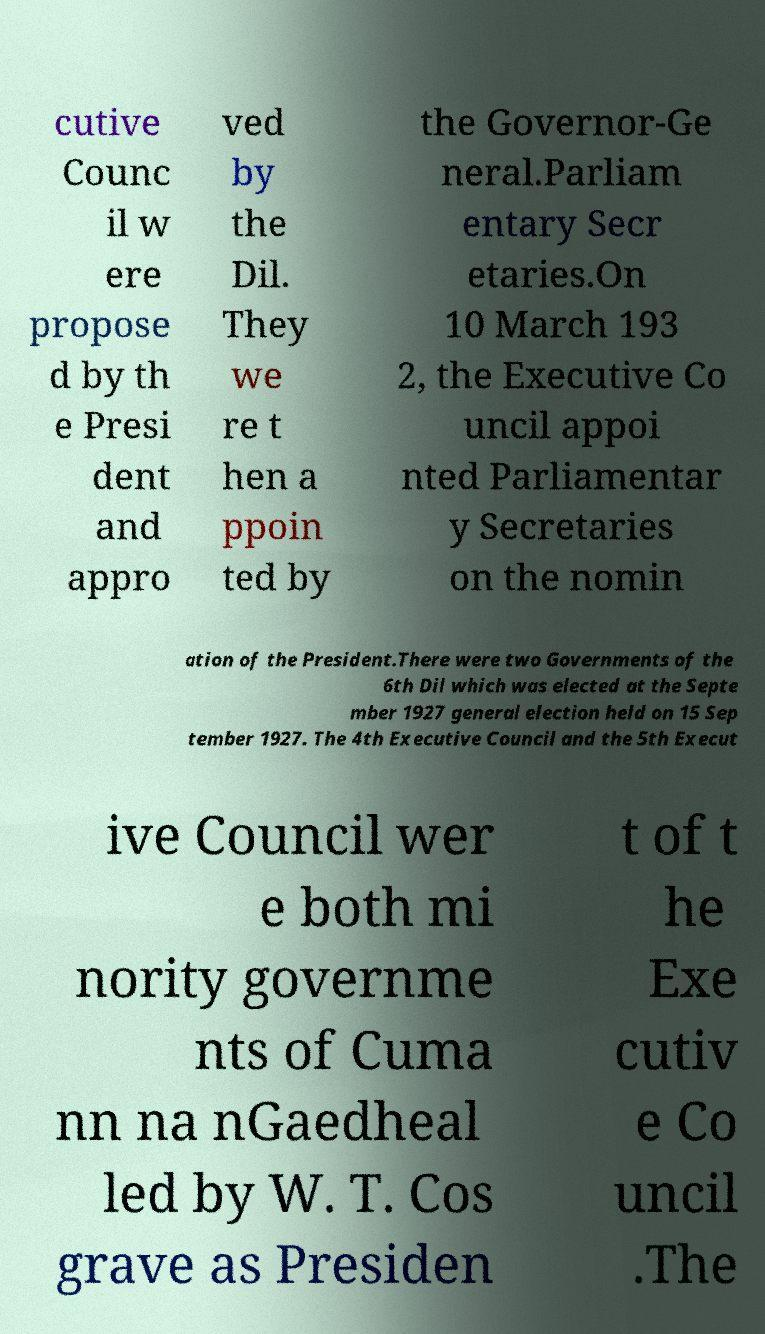Can you read and provide the text displayed in the image?This photo seems to have some interesting text. Can you extract and type it out for me? cutive Counc il w ere propose d by th e Presi dent and appro ved by the Dil. They we re t hen a ppoin ted by the Governor-Ge neral.Parliam entary Secr etaries.On 10 March 193 2, the Executive Co uncil appoi nted Parliamentar y Secretaries on the nomin ation of the President.There were two Governments of the 6th Dil which was elected at the Septe mber 1927 general election held on 15 Sep tember 1927. The 4th Executive Council and the 5th Execut ive Council wer e both mi nority governme nts of Cuma nn na nGaedheal led by W. T. Cos grave as Presiden t of t he Exe cutiv e Co uncil .The 